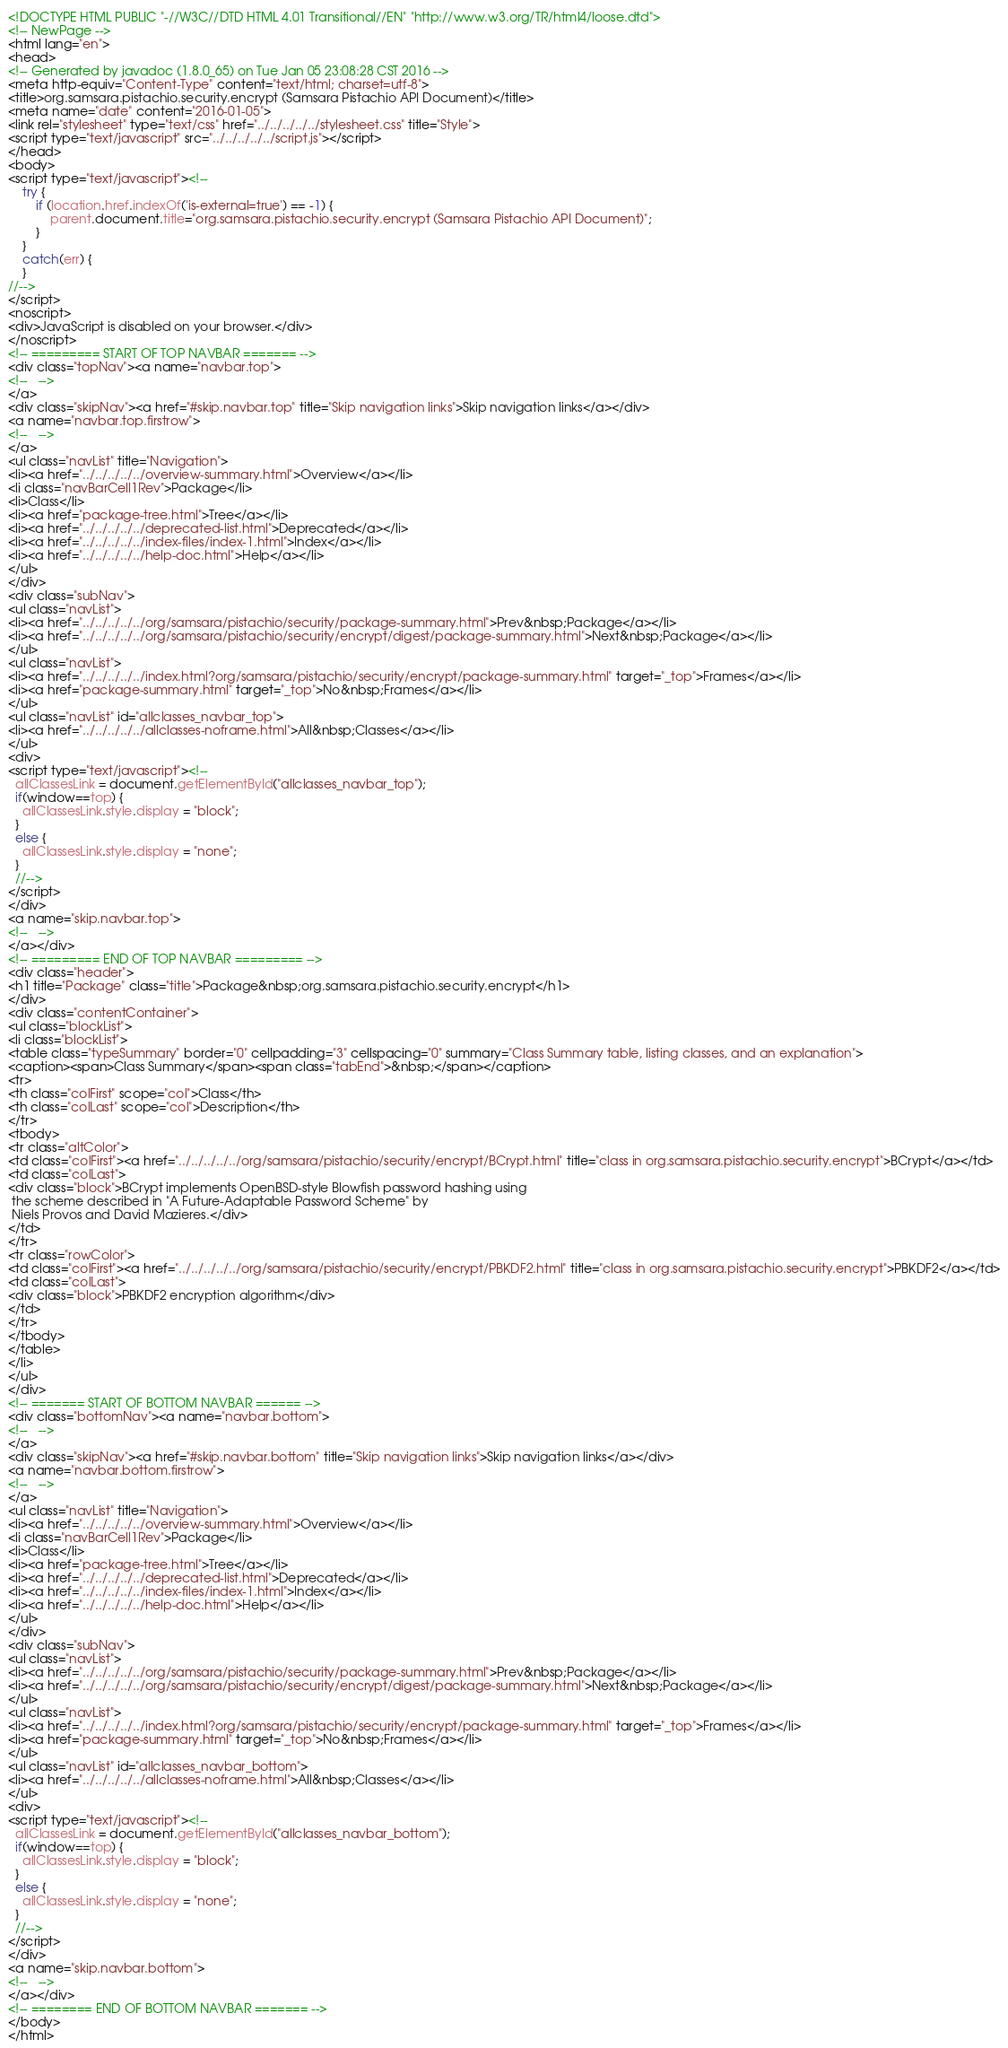Convert code to text. <code><loc_0><loc_0><loc_500><loc_500><_HTML_><!DOCTYPE HTML PUBLIC "-//W3C//DTD HTML 4.01 Transitional//EN" "http://www.w3.org/TR/html4/loose.dtd">
<!-- NewPage -->
<html lang="en">
<head>
<!-- Generated by javadoc (1.8.0_65) on Tue Jan 05 23:08:28 CST 2016 -->
<meta http-equiv="Content-Type" content="text/html; charset=utf-8">
<title>org.samsara.pistachio.security.encrypt (Samsara Pistachio API Document)</title>
<meta name="date" content="2016-01-05">
<link rel="stylesheet" type="text/css" href="../../../../../stylesheet.css" title="Style">
<script type="text/javascript" src="../../../../../script.js"></script>
</head>
<body>
<script type="text/javascript"><!--
    try {
        if (location.href.indexOf('is-external=true') == -1) {
            parent.document.title="org.samsara.pistachio.security.encrypt (Samsara Pistachio API Document)";
        }
    }
    catch(err) {
    }
//-->
</script>
<noscript>
<div>JavaScript is disabled on your browser.</div>
</noscript>
<!-- ========= START OF TOP NAVBAR ======= -->
<div class="topNav"><a name="navbar.top">
<!--   -->
</a>
<div class="skipNav"><a href="#skip.navbar.top" title="Skip navigation links">Skip navigation links</a></div>
<a name="navbar.top.firstrow">
<!--   -->
</a>
<ul class="navList" title="Navigation">
<li><a href="../../../../../overview-summary.html">Overview</a></li>
<li class="navBarCell1Rev">Package</li>
<li>Class</li>
<li><a href="package-tree.html">Tree</a></li>
<li><a href="../../../../../deprecated-list.html">Deprecated</a></li>
<li><a href="../../../../../index-files/index-1.html">Index</a></li>
<li><a href="../../../../../help-doc.html">Help</a></li>
</ul>
</div>
<div class="subNav">
<ul class="navList">
<li><a href="../../../../../org/samsara/pistachio/security/package-summary.html">Prev&nbsp;Package</a></li>
<li><a href="../../../../../org/samsara/pistachio/security/encrypt/digest/package-summary.html">Next&nbsp;Package</a></li>
</ul>
<ul class="navList">
<li><a href="../../../../../index.html?org/samsara/pistachio/security/encrypt/package-summary.html" target="_top">Frames</a></li>
<li><a href="package-summary.html" target="_top">No&nbsp;Frames</a></li>
</ul>
<ul class="navList" id="allclasses_navbar_top">
<li><a href="../../../../../allclasses-noframe.html">All&nbsp;Classes</a></li>
</ul>
<div>
<script type="text/javascript"><!--
  allClassesLink = document.getElementById("allclasses_navbar_top");
  if(window==top) {
    allClassesLink.style.display = "block";
  }
  else {
    allClassesLink.style.display = "none";
  }
  //-->
</script>
</div>
<a name="skip.navbar.top">
<!--   -->
</a></div>
<!-- ========= END OF TOP NAVBAR ========= -->
<div class="header">
<h1 title="Package" class="title">Package&nbsp;org.samsara.pistachio.security.encrypt</h1>
</div>
<div class="contentContainer">
<ul class="blockList">
<li class="blockList">
<table class="typeSummary" border="0" cellpadding="3" cellspacing="0" summary="Class Summary table, listing classes, and an explanation">
<caption><span>Class Summary</span><span class="tabEnd">&nbsp;</span></caption>
<tr>
<th class="colFirst" scope="col">Class</th>
<th class="colLast" scope="col">Description</th>
</tr>
<tbody>
<tr class="altColor">
<td class="colFirst"><a href="../../../../../org/samsara/pistachio/security/encrypt/BCrypt.html" title="class in org.samsara.pistachio.security.encrypt">BCrypt</a></td>
<td class="colLast">
<div class="block">BCrypt implements OpenBSD-style Blowfish password hashing using
 the scheme described in "A Future-Adaptable Password Scheme" by
 Niels Provos and David Mazieres.</div>
</td>
</tr>
<tr class="rowColor">
<td class="colFirst"><a href="../../../../../org/samsara/pistachio/security/encrypt/PBKDF2.html" title="class in org.samsara.pistachio.security.encrypt">PBKDF2</a></td>
<td class="colLast">
<div class="block">PBKDF2 encryption algorithm</div>
</td>
</tr>
</tbody>
</table>
</li>
</ul>
</div>
<!-- ======= START OF BOTTOM NAVBAR ====== -->
<div class="bottomNav"><a name="navbar.bottom">
<!--   -->
</a>
<div class="skipNav"><a href="#skip.navbar.bottom" title="Skip navigation links">Skip navigation links</a></div>
<a name="navbar.bottom.firstrow">
<!--   -->
</a>
<ul class="navList" title="Navigation">
<li><a href="../../../../../overview-summary.html">Overview</a></li>
<li class="navBarCell1Rev">Package</li>
<li>Class</li>
<li><a href="package-tree.html">Tree</a></li>
<li><a href="../../../../../deprecated-list.html">Deprecated</a></li>
<li><a href="../../../../../index-files/index-1.html">Index</a></li>
<li><a href="../../../../../help-doc.html">Help</a></li>
</ul>
</div>
<div class="subNav">
<ul class="navList">
<li><a href="../../../../../org/samsara/pistachio/security/package-summary.html">Prev&nbsp;Package</a></li>
<li><a href="../../../../../org/samsara/pistachio/security/encrypt/digest/package-summary.html">Next&nbsp;Package</a></li>
</ul>
<ul class="navList">
<li><a href="../../../../../index.html?org/samsara/pistachio/security/encrypt/package-summary.html" target="_top">Frames</a></li>
<li><a href="package-summary.html" target="_top">No&nbsp;Frames</a></li>
</ul>
<ul class="navList" id="allclasses_navbar_bottom">
<li><a href="../../../../../allclasses-noframe.html">All&nbsp;Classes</a></li>
</ul>
<div>
<script type="text/javascript"><!--
  allClassesLink = document.getElementById("allclasses_navbar_bottom");
  if(window==top) {
    allClassesLink.style.display = "block";
  }
  else {
    allClassesLink.style.display = "none";
  }
  //-->
</script>
</div>
<a name="skip.navbar.bottom">
<!--   -->
</a></div>
<!-- ======== END OF BOTTOM NAVBAR ======= -->
</body>
</html>
</code> 